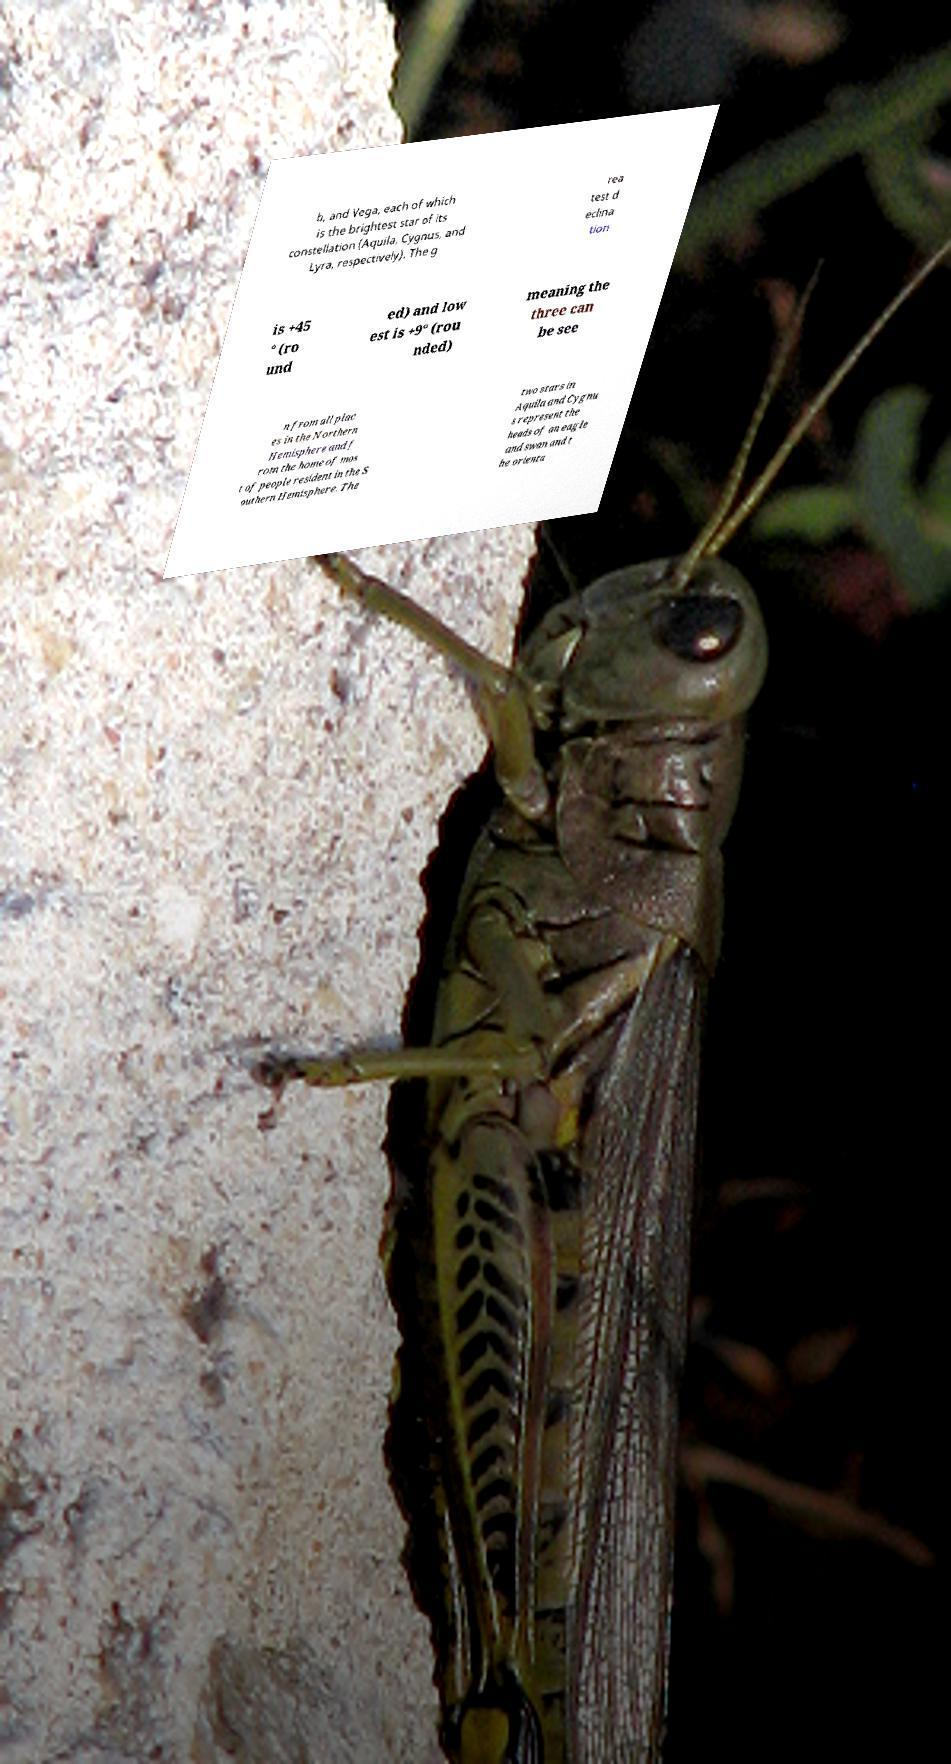Could you extract and type out the text from this image? b, and Vega, each of which is the brightest star of its constellation (Aquila, Cygnus, and Lyra, respectively). The g rea test d eclina tion is +45 ° (ro und ed) and low est is +9° (rou nded) meaning the three can be see n from all plac es in the Northern Hemisphere and f rom the home of mos t of people resident in the S outhern Hemisphere. The two stars in Aquila and Cygnu s represent the heads of an eagle and swan and t he orienta 